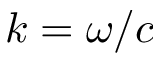Convert formula to latex. <formula><loc_0><loc_0><loc_500><loc_500>k = \omega / c</formula> 